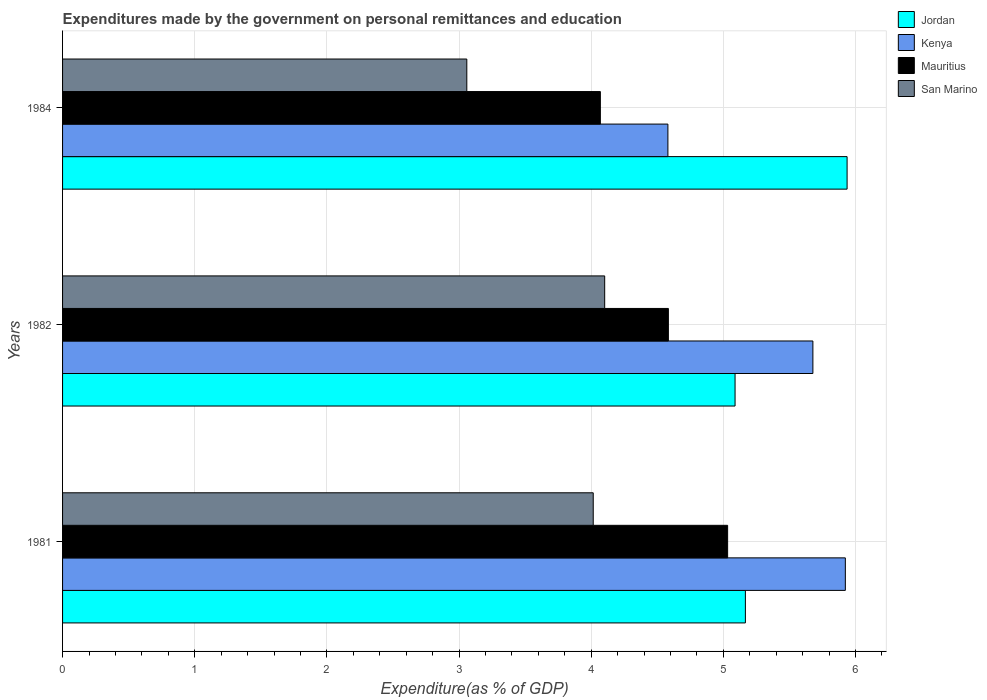How many different coloured bars are there?
Your response must be concise. 4. In how many cases, is the number of bars for a given year not equal to the number of legend labels?
Your response must be concise. 0. What is the expenditures made by the government on personal remittances and education in San Marino in 1984?
Offer a terse response. 3.06. Across all years, what is the maximum expenditures made by the government on personal remittances and education in Mauritius?
Your answer should be compact. 5.03. Across all years, what is the minimum expenditures made by the government on personal remittances and education in Mauritius?
Ensure brevity in your answer.  4.07. In which year was the expenditures made by the government on personal remittances and education in Kenya maximum?
Your answer should be very brief. 1981. In which year was the expenditures made by the government on personal remittances and education in San Marino minimum?
Your answer should be compact. 1984. What is the total expenditures made by the government on personal remittances and education in Mauritius in the graph?
Offer a very short reply. 13.69. What is the difference between the expenditures made by the government on personal remittances and education in Kenya in 1982 and that in 1984?
Provide a short and direct response. 1.1. What is the difference between the expenditures made by the government on personal remittances and education in Kenya in 1982 and the expenditures made by the government on personal remittances and education in Mauritius in 1984?
Keep it short and to the point. 1.61. What is the average expenditures made by the government on personal remittances and education in Jordan per year?
Your answer should be very brief. 5.4. In the year 1984, what is the difference between the expenditures made by the government on personal remittances and education in Mauritius and expenditures made by the government on personal remittances and education in San Marino?
Your answer should be very brief. 1.01. What is the ratio of the expenditures made by the government on personal remittances and education in Kenya in 1982 to that in 1984?
Ensure brevity in your answer.  1.24. Is the expenditures made by the government on personal remittances and education in San Marino in 1981 less than that in 1984?
Provide a short and direct response. No. What is the difference between the highest and the second highest expenditures made by the government on personal remittances and education in Jordan?
Your answer should be very brief. 0.77. What is the difference between the highest and the lowest expenditures made by the government on personal remittances and education in Mauritius?
Your answer should be compact. 0.96. In how many years, is the expenditures made by the government on personal remittances and education in Jordan greater than the average expenditures made by the government on personal remittances and education in Jordan taken over all years?
Your response must be concise. 1. Is it the case that in every year, the sum of the expenditures made by the government on personal remittances and education in Kenya and expenditures made by the government on personal remittances and education in San Marino is greater than the sum of expenditures made by the government on personal remittances and education in Jordan and expenditures made by the government on personal remittances and education in Mauritius?
Keep it short and to the point. Yes. What does the 2nd bar from the top in 1982 represents?
Your answer should be compact. Mauritius. What does the 4th bar from the bottom in 1981 represents?
Ensure brevity in your answer.  San Marino. Is it the case that in every year, the sum of the expenditures made by the government on personal remittances and education in Jordan and expenditures made by the government on personal remittances and education in San Marino is greater than the expenditures made by the government on personal remittances and education in Kenya?
Make the answer very short. Yes. How many bars are there?
Ensure brevity in your answer.  12. What is the difference between two consecutive major ticks on the X-axis?
Keep it short and to the point. 1. Where does the legend appear in the graph?
Ensure brevity in your answer.  Top right. What is the title of the graph?
Offer a terse response. Expenditures made by the government on personal remittances and education. Does "High income: nonOECD" appear as one of the legend labels in the graph?
Keep it short and to the point. No. What is the label or title of the X-axis?
Ensure brevity in your answer.  Expenditure(as % of GDP). What is the label or title of the Y-axis?
Make the answer very short. Years. What is the Expenditure(as % of GDP) of Jordan in 1981?
Offer a very short reply. 5.17. What is the Expenditure(as % of GDP) of Kenya in 1981?
Offer a terse response. 5.92. What is the Expenditure(as % of GDP) in Mauritius in 1981?
Keep it short and to the point. 5.03. What is the Expenditure(as % of GDP) of San Marino in 1981?
Give a very brief answer. 4.02. What is the Expenditure(as % of GDP) of Jordan in 1982?
Your answer should be very brief. 5.09. What is the Expenditure(as % of GDP) in Kenya in 1982?
Provide a short and direct response. 5.68. What is the Expenditure(as % of GDP) of Mauritius in 1982?
Ensure brevity in your answer.  4.58. What is the Expenditure(as % of GDP) of San Marino in 1982?
Give a very brief answer. 4.1. What is the Expenditure(as % of GDP) of Jordan in 1984?
Provide a succinct answer. 5.94. What is the Expenditure(as % of GDP) in Kenya in 1984?
Your response must be concise. 4.58. What is the Expenditure(as % of GDP) of Mauritius in 1984?
Offer a terse response. 4.07. What is the Expenditure(as % of GDP) of San Marino in 1984?
Your response must be concise. 3.06. Across all years, what is the maximum Expenditure(as % of GDP) of Jordan?
Provide a succinct answer. 5.94. Across all years, what is the maximum Expenditure(as % of GDP) in Kenya?
Offer a very short reply. 5.92. Across all years, what is the maximum Expenditure(as % of GDP) of Mauritius?
Provide a succinct answer. 5.03. Across all years, what is the maximum Expenditure(as % of GDP) in San Marino?
Your answer should be very brief. 4.1. Across all years, what is the minimum Expenditure(as % of GDP) in Jordan?
Your answer should be very brief. 5.09. Across all years, what is the minimum Expenditure(as % of GDP) of Kenya?
Your answer should be compact. 4.58. Across all years, what is the minimum Expenditure(as % of GDP) in Mauritius?
Your answer should be very brief. 4.07. Across all years, what is the minimum Expenditure(as % of GDP) of San Marino?
Give a very brief answer. 3.06. What is the total Expenditure(as % of GDP) in Jordan in the graph?
Offer a terse response. 16.19. What is the total Expenditure(as % of GDP) in Kenya in the graph?
Provide a succinct answer. 16.18. What is the total Expenditure(as % of GDP) of Mauritius in the graph?
Your response must be concise. 13.69. What is the total Expenditure(as % of GDP) of San Marino in the graph?
Your response must be concise. 11.18. What is the difference between the Expenditure(as % of GDP) in Jordan in 1981 and that in 1982?
Provide a succinct answer. 0.08. What is the difference between the Expenditure(as % of GDP) in Kenya in 1981 and that in 1982?
Provide a short and direct response. 0.25. What is the difference between the Expenditure(as % of GDP) in Mauritius in 1981 and that in 1982?
Offer a terse response. 0.45. What is the difference between the Expenditure(as % of GDP) of San Marino in 1981 and that in 1982?
Keep it short and to the point. -0.09. What is the difference between the Expenditure(as % of GDP) of Jordan in 1981 and that in 1984?
Your answer should be very brief. -0.77. What is the difference between the Expenditure(as % of GDP) in Kenya in 1981 and that in 1984?
Offer a terse response. 1.34. What is the difference between the Expenditure(as % of GDP) of Mauritius in 1981 and that in 1984?
Your answer should be very brief. 0.96. What is the difference between the Expenditure(as % of GDP) in San Marino in 1981 and that in 1984?
Offer a very short reply. 0.96. What is the difference between the Expenditure(as % of GDP) in Jordan in 1982 and that in 1984?
Provide a short and direct response. -0.85. What is the difference between the Expenditure(as % of GDP) in Kenya in 1982 and that in 1984?
Your response must be concise. 1.1. What is the difference between the Expenditure(as % of GDP) of Mauritius in 1982 and that in 1984?
Keep it short and to the point. 0.51. What is the difference between the Expenditure(as % of GDP) in San Marino in 1982 and that in 1984?
Offer a terse response. 1.04. What is the difference between the Expenditure(as % of GDP) of Jordan in 1981 and the Expenditure(as % of GDP) of Kenya in 1982?
Provide a succinct answer. -0.51. What is the difference between the Expenditure(as % of GDP) in Jordan in 1981 and the Expenditure(as % of GDP) in Mauritius in 1982?
Give a very brief answer. 0.58. What is the difference between the Expenditure(as % of GDP) in Jordan in 1981 and the Expenditure(as % of GDP) in San Marino in 1982?
Ensure brevity in your answer.  1.06. What is the difference between the Expenditure(as % of GDP) in Kenya in 1981 and the Expenditure(as % of GDP) in Mauritius in 1982?
Offer a terse response. 1.34. What is the difference between the Expenditure(as % of GDP) in Kenya in 1981 and the Expenditure(as % of GDP) in San Marino in 1982?
Offer a terse response. 1.82. What is the difference between the Expenditure(as % of GDP) in Mauritius in 1981 and the Expenditure(as % of GDP) in San Marino in 1982?
Provide a succinct answer. 0.93. What is the difference between the Expenditure(as % of GDP) in Jordan in 1981 and the Expenditure(as % of GDP) in Kenya in 1984?
Your answer should be compact. 0.59. What is the difference between the Expenditure(as % of GDP) of Jordan in 1981 and the Expenditure(as % of GDP) of Mauritius in 1984?
Offer a terse response. 1.1. What is the difference between the Expenditure(as % of GDP) in Jordan in 1981 and the Expenditure(as % of GDP) in San Marino in 1984?
Make the answer very short. 2.11. What is the difference between the Expenditure(as % of GDP) in Kenya in 1981 and the Expenditure(as % of GDP) in Mauritius in 1984?
Make the answer very short. 1.85. What is the difference between the Expenditure(as % of GDP) in Kenya in 1981 and the Expenditure(as % of GDP) in San Marino in 1984?
Give a very brief answer. 2.86. What is the difference between the Expenditure(as % of GDP) in Mauritius in 1981 and the Expenditure(as % of GDP) in San Marino in 1984?
Keep it short and to the point. 1.97. What is the difference between the Expenditure(as % of GDP) of Jordan in 1982 and the Expenditure(as % of GDP) of Kenya in 1984?
Make the answer very short. 0.51. What is the difference between the Expenditure(as % of GDP) in Jordan in 1982 and the Expenditure(as % of GDP) in Mauritius in 1984?
Provide a short and direct response. 1.02. What is the difference between the Expenditure(as % of GDP) of Jordan in 1982 and the Expenditure(as % of GDP) of San Marino in 1984?
Offer a terse response. 2.03. What is the difference between the Expenditure(as % of GDP) in Kenya in 1982 and the Expenditure(as % of GDP) in Mauritius in 1984?
Provide a succinct answer. 1.61. What is the difference between the Expenditure(as % of GDP) of Kenya in 1982 and the Expenditure(as % of GDP) of San Marino in 1984?
Provide a short and direct response. 2.62. What is the difference between the Expenditure(as % of GDP) of Mauritius in 1982 and the Expenditure(as % of GDP) of San Marino in 1984?
Ensure brevity in your answer.  1.53. What is the average Expenditure(as % of GDP) in Jordan per year?
Your response must be concise. 5.4. What is the average Expenditure(as % of GDP) of Kenya per year?
Ensure brevity in your answer.  5.39. What is the average Expenditure(as % of GDP) of Mauritius per year?
Ensure brevity in your answer.  4.56. What is the average Expenditure(as % of GDP) in San Marino per year?
Offer a terse response. 3.73. In the year 1981, what is the difference between the Expenditure(as % of GDP) in Jordan and Expenditure(as % of GDP) in Kenya?
Provide a succinct answer. -0.76. In the year 1981, what is the difference between the Expenditure(as % of GDP) in Jordan and Expenditure(as % of GDP) in Mauritius?
Make the answer very short. 0.13. In the year 1981, what is the difference between the Expenditure(as % of GDP) in Jordan and Expenditure(as % of GDP) in San Marino?
Ensure brevity in your answer.  1.15. In the year 1981, what is the difference between the Expenditure(as % of GDP) of Kenya and Expenditure(as % of GDP) of Mauritius?
Offer a terse response. 0.89. In the year 1981, what is the difference between the Expenditure(as % of GDP) of Kenya and Expenditure(as % of GDP) of San Marino?
Give a very brief answer. 1.91. In the year 1981, what is the difference between the Expenditure(as % of GDP) of Mauritius and Expenditure(as % of GDP) of San Marino?
Keep it short and to the point. 1.02. In the year 1982, what is the difference between the Expenditure(as % of GDP) in Jordan and Expenditure(as % of GDP) in Kenya?
Give a very brief answer. -0.59. In the year 1982, what is the difference between the Expenditure(as % of GDP) of Jordan and Expenditure(as % of GDP) of Mauritius?
Your response must be concise. 0.5. In the year 1982, what is the difference between the Expenditure(as % of GDP) of Jordan and Expenditure(as % of GDP) of San Marino?
Ensure brevity in your answer.  0.99. In the year 1982, what is the difference between the Expenditure(as % of GDP) of Kenya and Expenditure(as % of GDP) of Mauritius?
Ensure brevity in your answer.  1.09. In the year 1982, what is the difference between the Expenditure(as % of GDP) in Kenya and Expenditure(as % of GDP) in San Marino?
Give a very brief answer. 1.58. In the year 1982, what is the difference between the Expenditure(as % of GDP) in Mauritius and Expenditure(as % of GDP) in San Marino?
Your response must be concise. 0.48. In the year 1984, what is the difference between the Expenditure(as % of GDP) of Jordan and Expenditure(as % of GDP) of Kenya?
Keep it short and to the point. 1.36. In the year 1984, what is the difference between the Expenditure(as % of GDP) of Jordan and Expenditure(as % of GDP) of Mauritius?
Your answer should be very brief. 1.87. In the year 1984, what is the difference between the Expenditure(as % of GDP) in Jordan and Expenditure(as % of GDP) in San Marino?
Your response must be concise. 2.88. In the year 1984, what is the difference between the Expenditure(as % of GDP) of Kenya and Expenditure(as % of GDP) of Mauritius?
Offer a very short reply. 0.51. In the year 1984, what is the difference between the Expenditure(as % of GDP) of Kenya and Expenditure(as % of GDP) of San Marino?
Your response must be concise. 1.52. In the year 1984, what is the difference between the Expenditure(as % of GDP) in Mauritius and Expenditure(as % of GDP) in San Marino?
Offer a terse response. 1.01. What is the ratio of the Expenditure(as % of GDP) of Jordan in 1981 to that in 1982?
Offer a terse response. 1.02. What is the ratio of the Expenditure(as % of GDP) in Kenya in 1981 to that in 1982?
Offer a very short reply. 1.04. What is the ratio of the Expenditure(as % of GDP) of Mauritius in 1981 to that in 1982?
Your answer should be very brief. 1.1. What is the ratio of the Expenditure(as % of GDP) of San Marino in 1981 to that in 1982?
Your response must be concise. 0.98. What is the ratio of the Expenditure(as % of GDP) in Jordan in 1981 to that in 1984?
Provide a short and direct response. 0.87. What is the ratio of the Expenditure(as % of GDP) of Kenya in 1981 to that in 1984?
Provide a short and direct response. 1.29. What is the ratio of the Expenditure(as % of GDP) in Mauritius in 1981 to that in 1984?
Provide a short and direct response. 1.24. What is the ratio of the Expenditure(as % of GDP) in San Marino in 1981 to that in 1984?
Keep it short and to the point. 1.31. What is the ratio of the Expenditure(as % of GDP) of Jordan in 1982 to that in 1984?
Offer a very short reply. 0.86. What is the ratio of the Expenditure(as % of GDP) in Kenya in 1982 to that in 1984?
Your answer should be very brief. 1.24. What is the ratio of the Expenditure(as % of GDP) of Mauritius in 1982 to that in 1984?
Your response must be concise. 1.13. What is the ratio of the Expenditure(as % of GDP) in San Marino in 1982 to that in 1984?
Your answer should be compact. 1.34. What is the difference between the highest and the second highest Expenditure(as % of GDP) of Jordan?
Offer a terse response. 0.77. What is the difference between the highest and the second highest Expenditure(as % of GDP) in Kenya?
Give a very brief answer. 0.25. What is the difference between the highest and the second highest Expenditure(as % of GDP) of Mauritius?
Your response must be concise. 0.45. What is the difference between the highest and the second highest Expenditure(as % of GDP) of San Marino?
Offer a terse response. 0.09. What is the difference between the highest and the lowest Expenditure(as % of GDP) in Jordan?
Offer a terse response. 0.85. What is the difference between the highest and the lowest Expenditure(as % of GDP) of Kenya?
Your answer should be very brief. 1.34. What is the difference between the highest and the lowest Expenditure(as % of GDP) in Mauritius?
Offer a very short reply. 0.96. What is the difference between the highest and the lowest Expenditure(as % of GDP) of San Marino?
Offer a terse response. 1.04. 